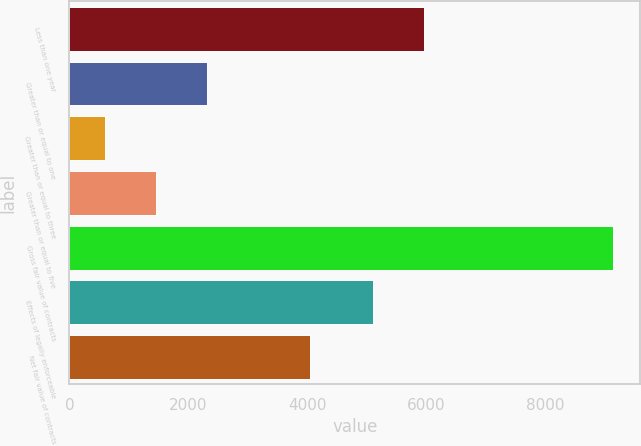Convert chart. <chart><loc_0><loc_0><loc_500><loc_500><bar_chart><fcel>Less than one year<fcel>Greater than or equal to one<fcel>Greater than or equal to three<fcel>Greater than or equal to five<fcel>Gross fair value of contracts<fcel>Effects of legally enforceable<fcel>Net fair value of contracts<nl><fcel>5964.8<fcel>2312.6<fcel>603<fcel>1457.8<fcel>9151<fcel>5110<fcel>4041<nl></chart> 